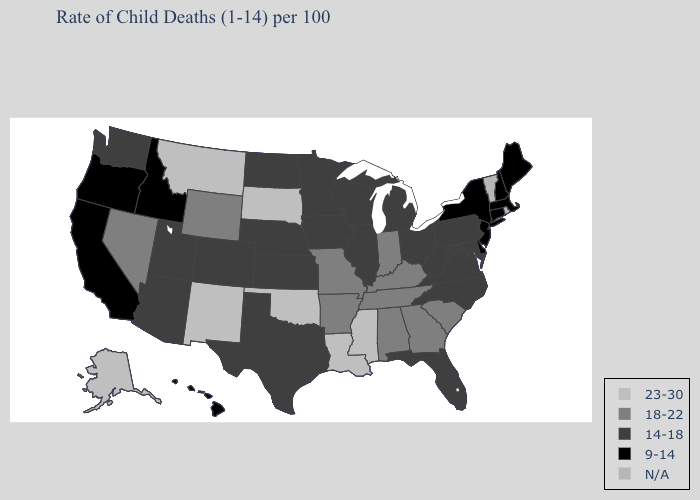Name the states that have a value in the range N/A?
Be succinct. Rhode Island, Vermont. Name the states that have a value in the range 14-18?
Short answer required. Arizona, Colorado, Florida, Illinois, Iowa, Kansas, Maryland, Michigan, Minnesota, Nebraska, North Carolina, North Dakota, Ohio, Pennsylvania, Texas, Utah, Virginia, Washington, West Virginia, Wisconsin. What is the highest value in states that border Minnesota?
Write a very short answer. 23-30. What is the value of New Mexico?
Concise answer only. 23-30. Which states have the highest value in the USA?
Write a very short answer. Alaska, Louisiana, Mississippi, Montana, New Mexico, Oklahoma, South Dakota. What is the highest value in states that border North Carolina?
Short answer required. 18-22. What is the highest value in the USA?
Quick response, please. 23-30. Does Oregon have the lowest value in the USA?
Write a very short answer. Yes. Does Missouri have the lowest value in the MidWest?
Write a very short answer. No. What is the value of North Carolina?
Quick response, please. 14-18. Does South Dakota have the highest value in the USA?
Keep it brief. Yes. Which states hav the highest value in the MidWest?
Be succinct. South Dakota. What is the lowest value in states that border Missouri?
Keep it brief. 14-18. 